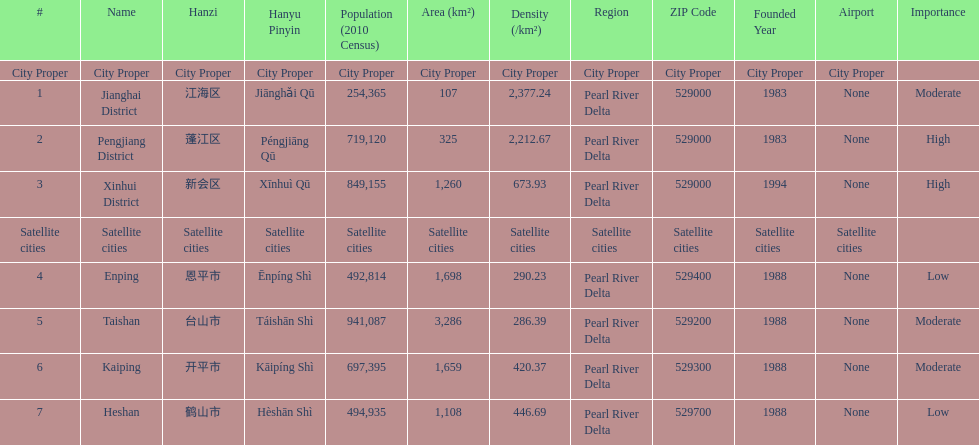What is the difference in population between enping and heshan? 2121. 